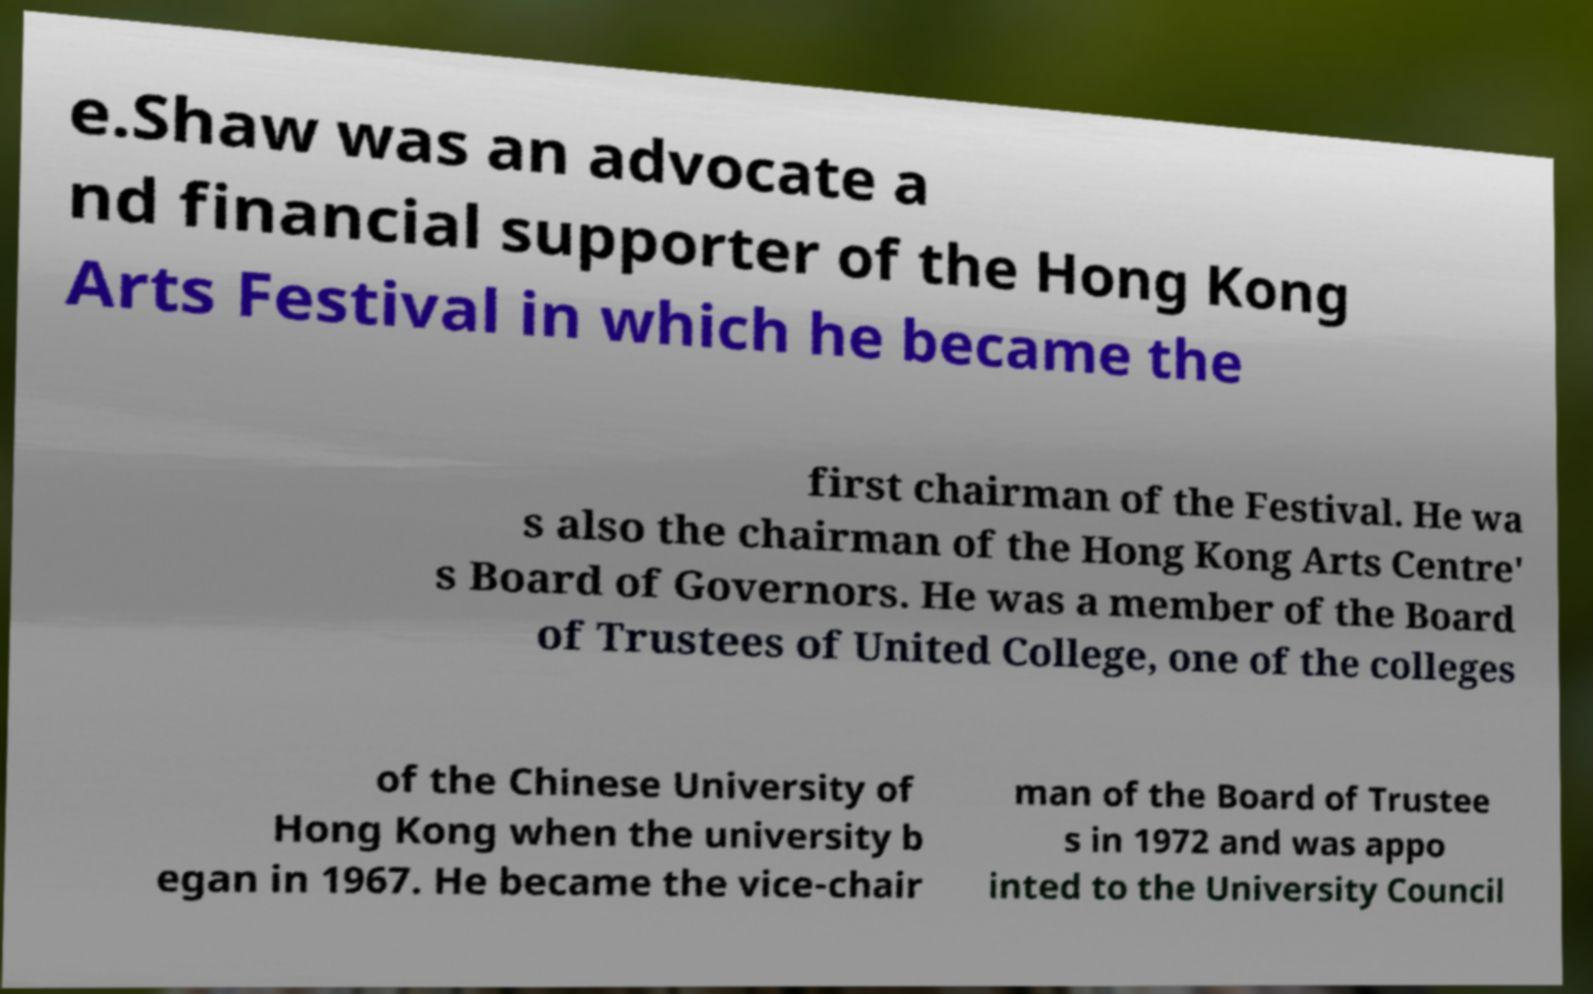Please read and relay the text visible in this image. What does it say? e.Shaw was an advocate a nd financial supporter of the Hong Kong Arts Festival in which he became the first chairman of the Festival. He wa s also the chairman of the Hong Kong Arts Centre' s Board of Governors. He was a member of the Board of Trustees of United College, one of the colleges of the Chinese University of Hong Kong when the university b egan in 1967. He became the vice-chair man of the Board of Trustee s in 1972 and was appo inted to the University Council 